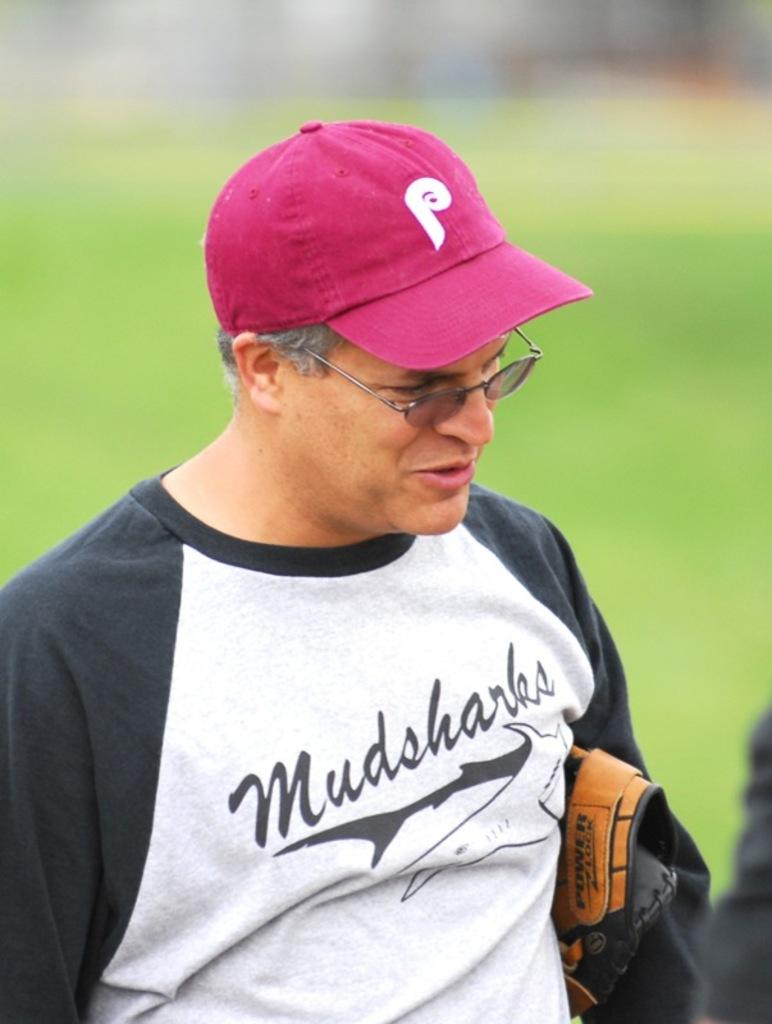What is the main subject of the image? There is a person in the image. Can you describe the person's appearance? The person is wearing spectacles and a cap. How would you describe the background of the image? The background of the image is blurry. What type of jewel is the person holding in the image? There is no jewel present in the image; the person is wearing spectacles and a cap. Can you see a monkey in the image? There is no monkey present in the image; the main subject is a person wearing spectacles and a cap. 